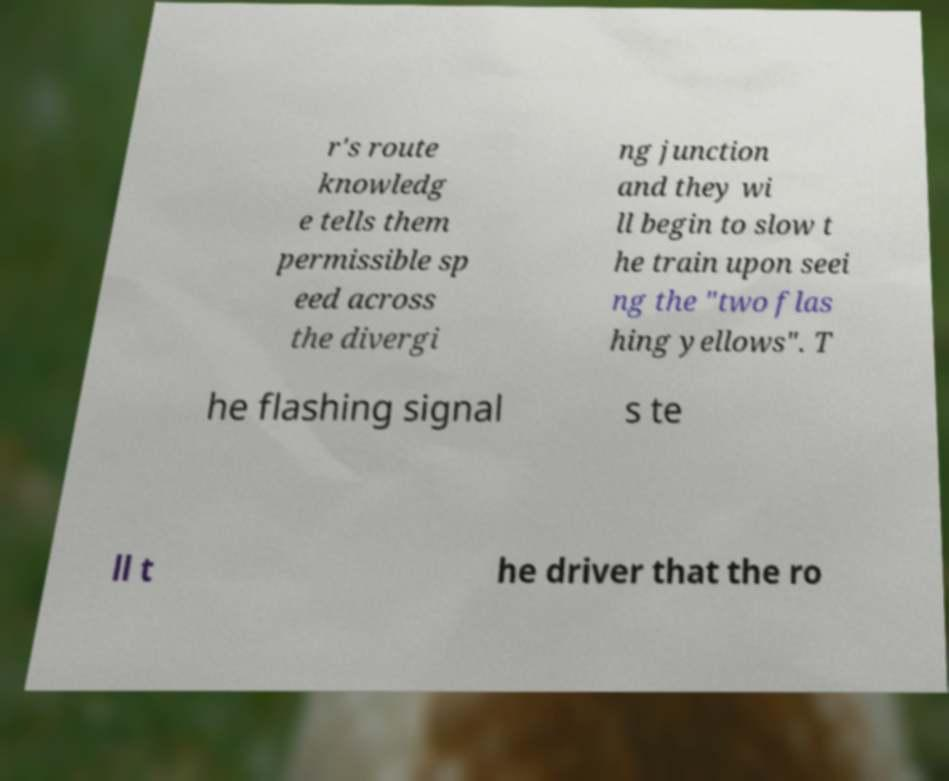Please identify and transcribe the text found in this image. r's route knowledg e tells them permissible sp eed across the divergi ng junction and they wi ll begin to slow t he train upon seei ng the "two flas hing yellows". T he flashing signal s te ll t he driver that the ro 